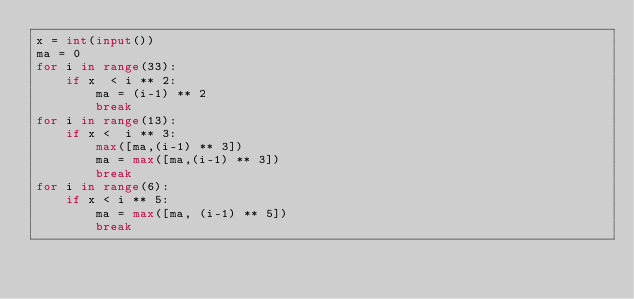<code> <loc_0><loc_0><loc_500><loc_500><_Python_>x = int(input())
ma = 0
for i in range(33):
    if x  < i ** 2:
        ma = (i-1) ** 2
        break
for i in range(13):
    if x <  i ** 3:
        max([ma,(i-1) ** 3])
        ma = max([ma,(i-1) ** 3])
        break
for i in range(6):
    if x < i ** 5:
        ma = max([ma, (i-1) ** 5])
        break
</code> 